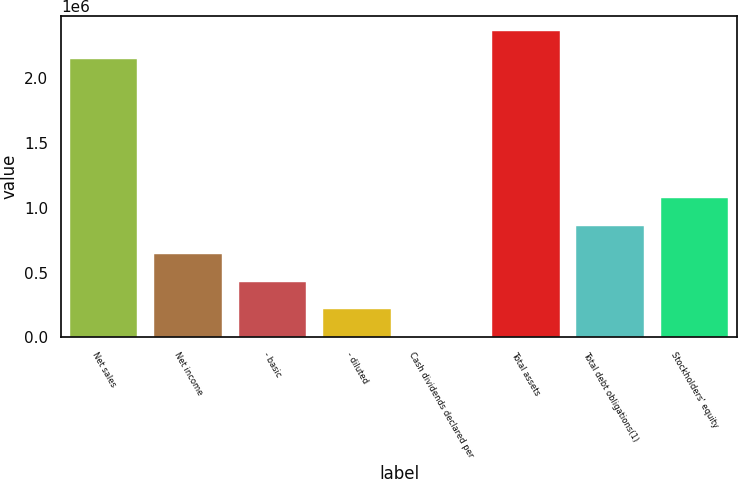<chart> <loc_0><loc_0><loc_500><loc_500><bar_chart><fcel>Net sales<fcel>Net income<fcel>- basic<fcel>- diluted<fcel>Cash dividends declared per<fcel>Total assets<fcel>Total debt obligations(1)<fcel>Stockholders' equity<nl><fcel>2.14759e+06<fcel>645852<fcel>430568<fcel>215285<fcel>0.6<fcel>2.36287e+06<fcel>861136<fcel>1.07642e+06<nl></chart> 